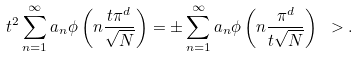Convert formula to latex. <formula><loc_0><loc_0><loc_500><loc_500>t ^ { 2 } \sum _ { n = 1 } ^ { \infty } a _ { n } \phi \left ( n \frac { t \pi ^ { d } } { \sqrt { N } } \right ) = \pm \sum _ { n = 1 } ^ { \infty } a _ { n } \phi \left ( n \frac { \pi ^ { d } } { t \sqrt { N } } \right ) \ > .</formula> 